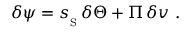Convert formula to latex. <formula><loc_0><loc_0><loc_500><loc_500>\delta \psi = { s _ { _ { S } } } \, \delta \Theta + { \mathit \Pi } \, \delta v \ .</formula> 